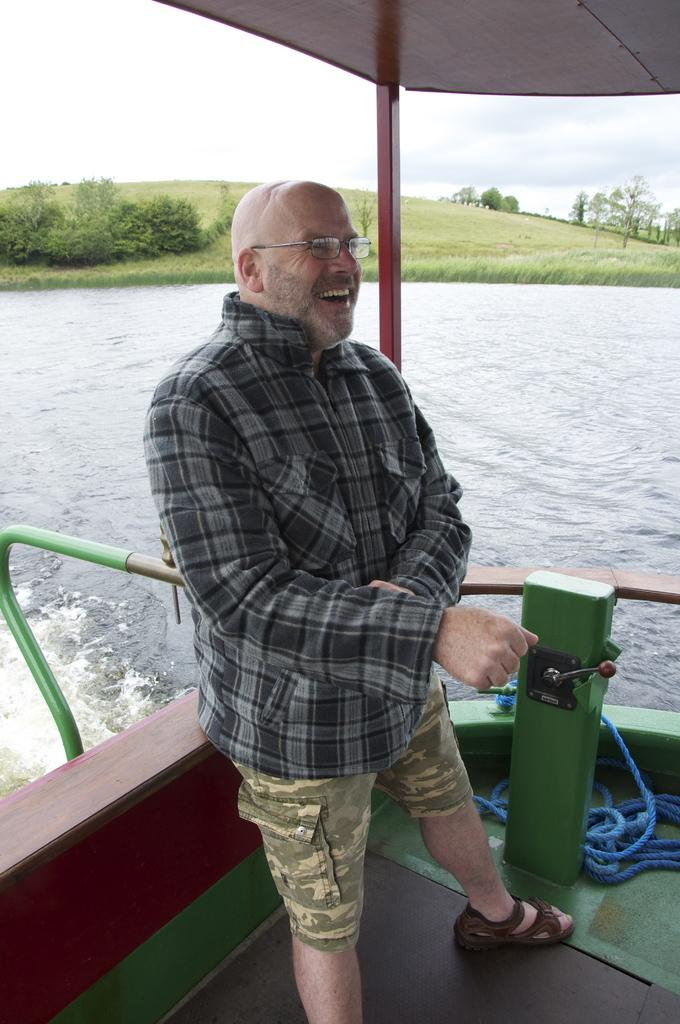What is the main subject of the image? There is a man standing in the center of the image. What is the man's facial expression? The man is smiling. What can be seen in the background of the image? There is water, plants, and trees in the background of the image. What type of vegetation is present on the ground in the image? There is grass on the ground in the image. What type of sponge is being used to clean the channel in the image? There is no sponge or channel present in the image; it features a man standing in the center with a background of water, plants, and trees. 